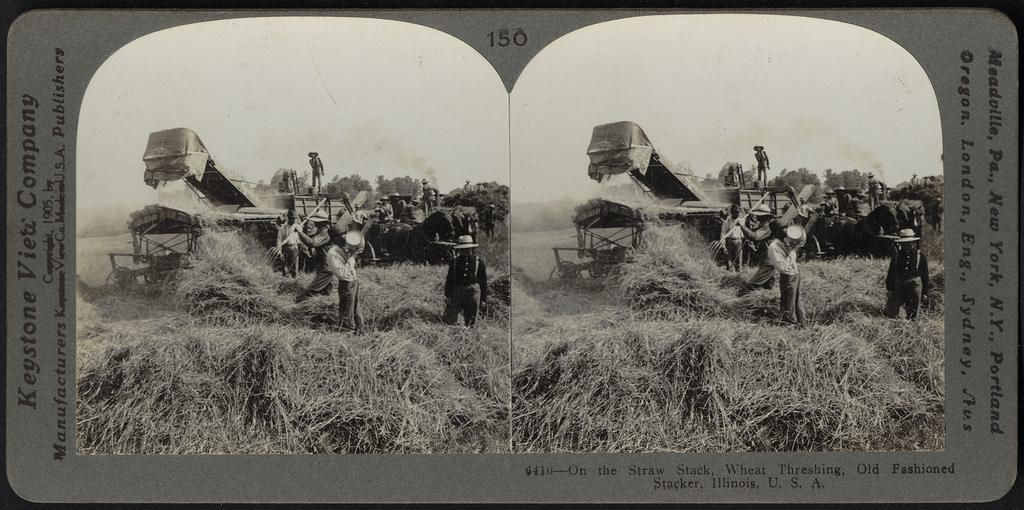<image>
Share a concise interpretation of the image provided. An old black and white picture captioned Keystone Viete Company. 